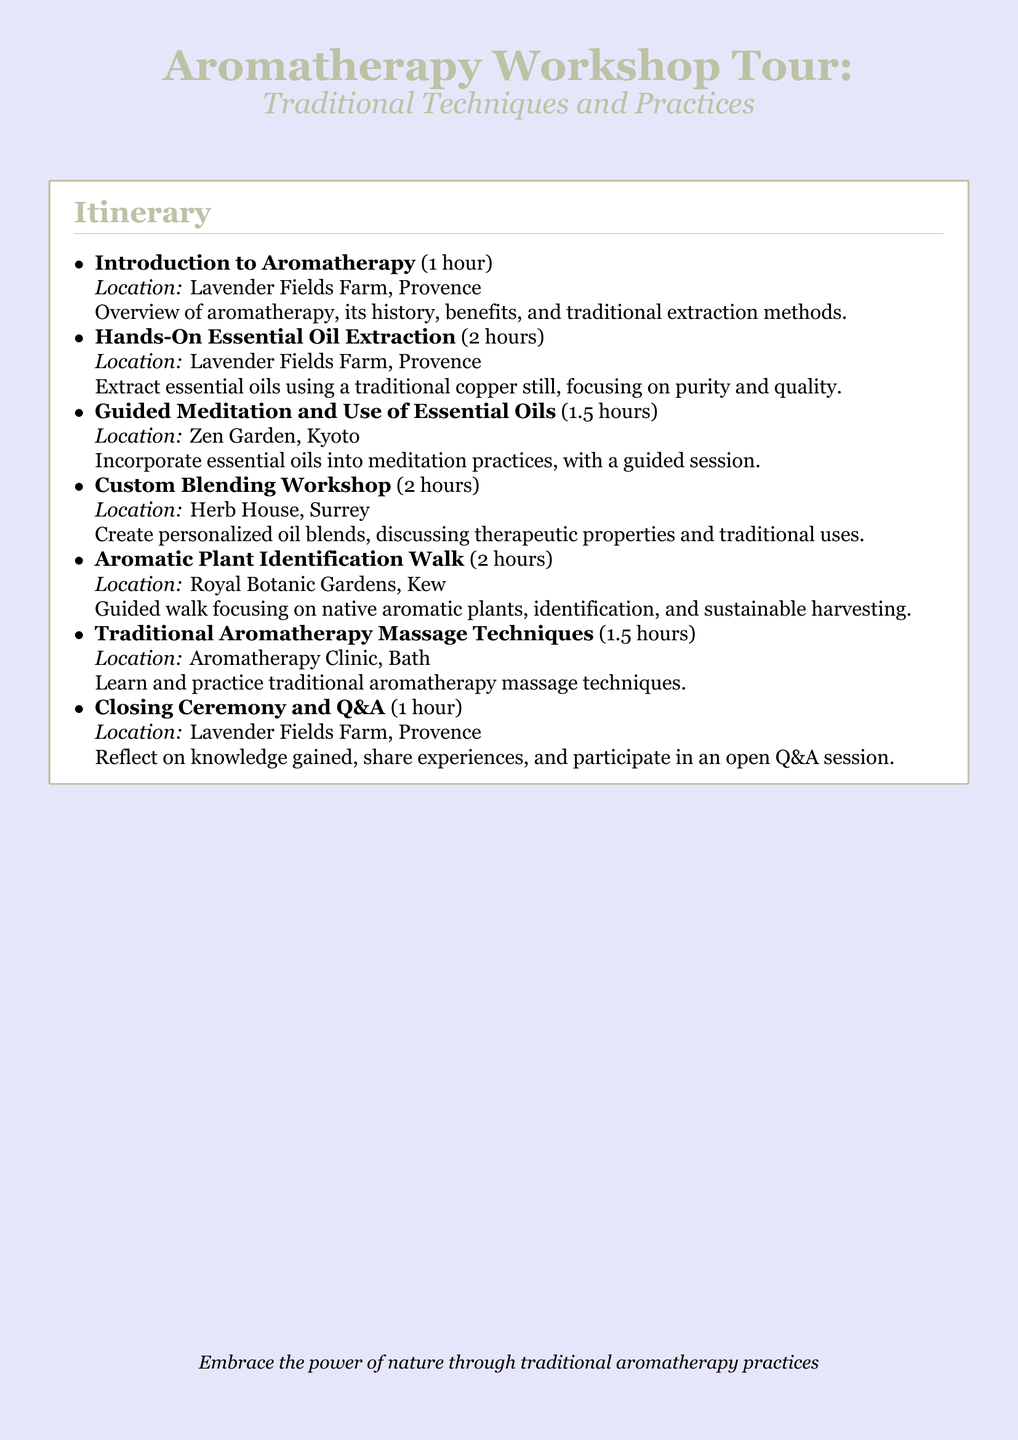what is the duration of the introduction to aromatherapy? The document states that the introduction lasts for 1 hour.
Answer: 1 hour what is the location for the hands-on essential oil extraction? According to the itinerary, the location for this session is Lavender Fields Farm, Provence.
Answer: Lavender Fields Farm, Provence how many hours are dedicated to the custom blending workshop? The itinerary specifies that the custom blending workshop lasts for 2 hours.
Answer: 2 hours what practice incorporates essential oils in the guided session? The document mentions that essential oils are incorporated into guided meditation practices.
Answer: Guided meditation which location features the aromatic plant identification walk? The itinerary lists Royal Botanic Gardens, Kew as the location for the identification walk.
Answer: Royal Botanic Gardens, Kew how long is the closing ceremony and Q&A session? This session is designated to last for 1 hour.
Answer: 1 hour what skills are learned in the traditional aromatherapy massage techniques session? The document states that participants learn and practice traditional aromatherapy massage techniques.
Answer: Traditional aromatherapy massage techniques how many total hours does the itinerary cover? By adding the hours from each session, the total duration is 10 hours.
Answer: 10 hours which location hosts the closing ceremony? The closing ceremony is hosted at Lavender Fields Farm, Provence.
Answer: Lavender Fields Farm, Provence 